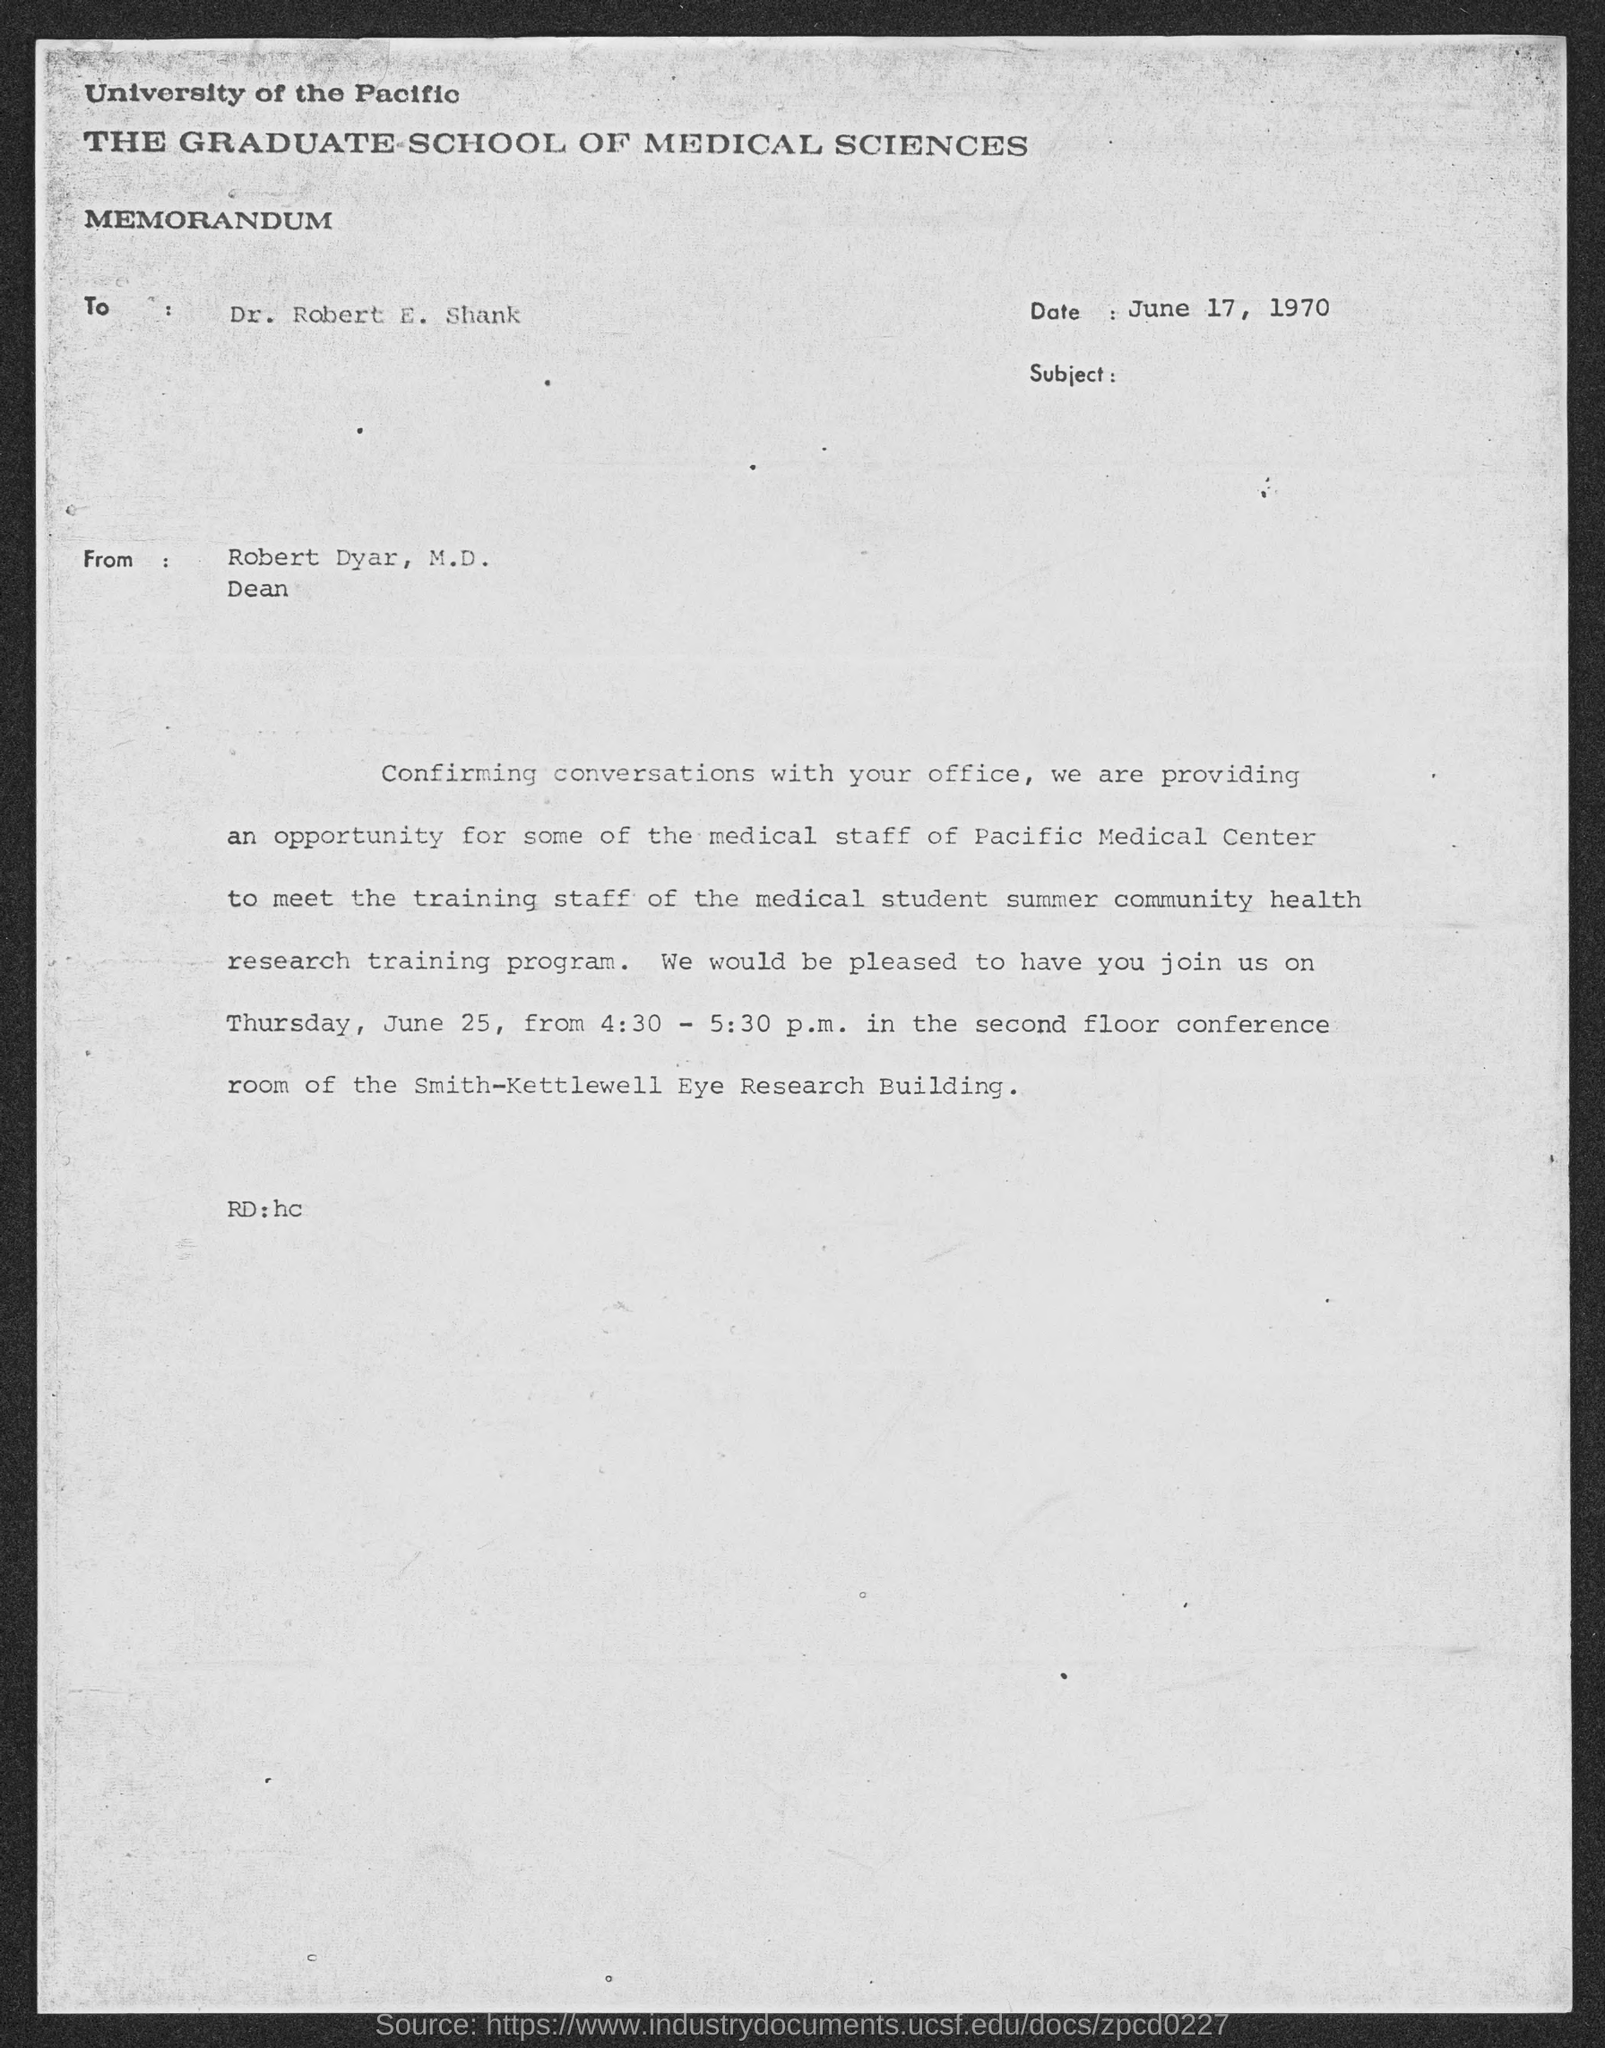Mention a couple of crucial points in this snapshot. The letter was written by Robert Dyar, M.D. The memorandum was dated June 17, 1970. The letter is addressed to Dr. Robert E. Shank. 